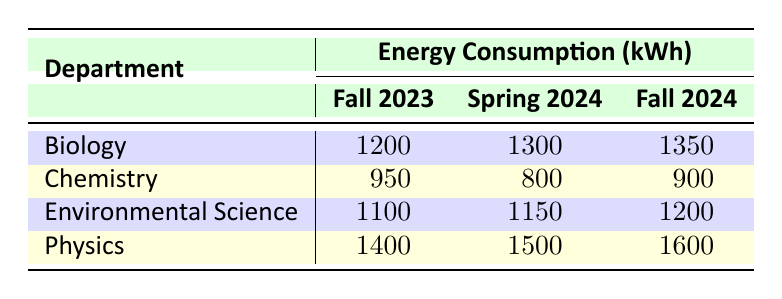What's the energy consumption of the Chemistry department in Fall 2023? From the table, we can locate the row for the Chemistry department and the column for Fall 2023. The value corresponding to these is 950 kWh.
Answer: 950 What is the total energy consumption of the Environmental Science department across all semesters? The table shows the following values for Environmental Science: 1100 kWh in Fall 2023, 1150 kWh in Spring 2024, and 1200 kWh in Fall 2024. Adding them gives us: 1100 + 1150 + 1200 = 3450 kWh.
Answer: 3450 Did the Physics department consume more energy in Spring 2024 than in Fall 2023? Looking at the Physics department, we see they consumed 1500 kWh in Spring 2024 and 1400 kWh in Fall 2023. Since 1500 is greater than 1400, the answer is yes.
Answer: Yes What is the increase in energy consumption for Biology from Fall 2023 to Fall 2024? For Biology, the energy consumption in Fall 2023 is 1200 kWh and in Fall 2024 is 1350 kWh. The increase is calculated as 1350 - 1200 = 150 kWh.
Answer: 150 Which department had the maximum energy consumption in Spring 2024? In Spring 2024, the energy consumptions are: Biology 1300 kWh, Chemistry 800 kWh, Environmental Science 1150 kWh, and Physics 1500 kWh. The highest value is from Physics, so the answer is Physics.
Answer: Physics What is the average energy consumption of the Chemistry department over the three semesters? The values for Chemistry are 950 kWh in Fall 2023, 800 kWh in Spring 2024, and 900 kWh in Fall 2024. The sum is 950 + 800 + 900 = 2650 kWh. There are 3 semesters, so the average is 2650 / 3 = approximately 883.33 kWh.
Answer: 883.33 Is it true that the Environmental Science department has had consistent energy consumption over the semesters (i.e., no decrease)? The data shows: 1100 kWh in Fall 2023, 1150 kWh in Spring 2024, and 1200 kWh in Fall 2024. Each value is greater than the last, indicating that there is no decrease. Therefore, the statement is true.
Answer: Yes What was the total energy consumption of all departments in Fall 2024? The energy consumptions in Fall 2024 are: Biology 1350 kWh, Chemistry 900 kWh, Environmental Science 1200 kWh, and Physics 1600 kWh. Adding these gives 1350 + 900 + 1200 + 1600 = 4050 kWh.
Answer: 4050 What is the difference in energy consumption between the Physics and Biology departments in Fall 2024? The energy consumption for Physics in Fall 2024 is 1600 kWh, and for Biology, it is 1350 kWh. The difference is calculated as 1600 - 1350 = 250 kWh.
Answer: 250 Which semester had the lowest total energy consumption across all departments? To find this, we sum the energy consumption for each semester: Fall 2023 = 1200 + 950 + 1100 + 1400 = 3650 kWh; Spring 2024 = 1300 + 800 + 1150 + 1500 = 3750 kWh; Fall 2024 = 1350 + 900 + 1200 + 1600 = 4050 kWh. The lowest total is from Fall 2023 at 3650 kWh.
Answer: Fall 2023 